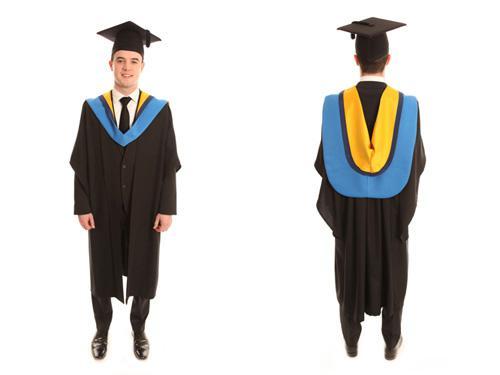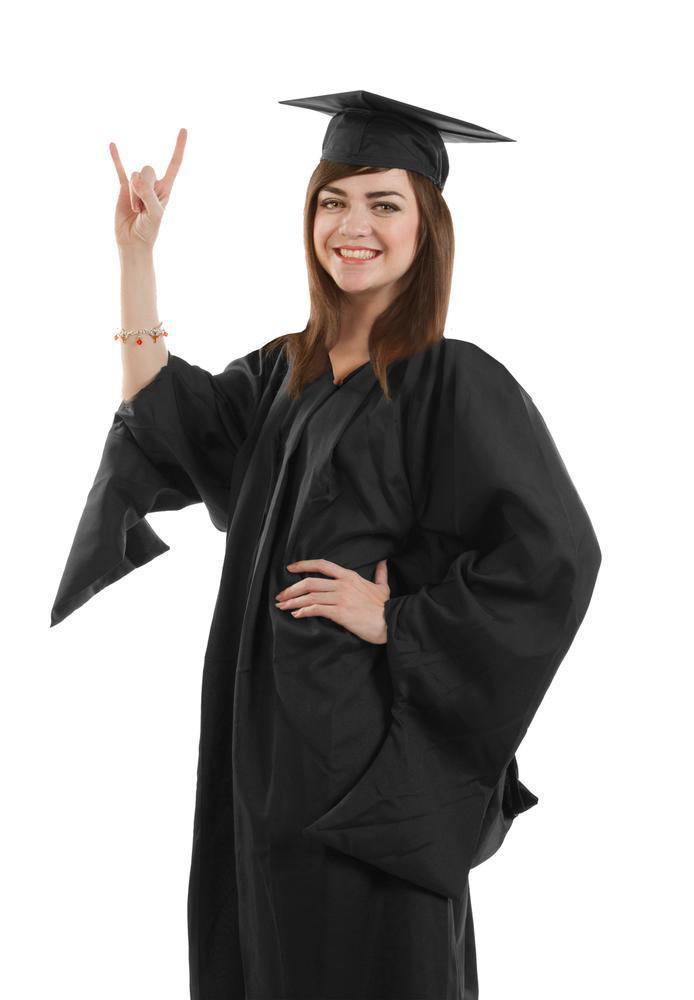The first image is the image on the left, the second image is the image on the right. Examine the images to the left and right. Is the description "Only two different people wearing gowns are visible." accurate? Answer yes or no. Yes. 